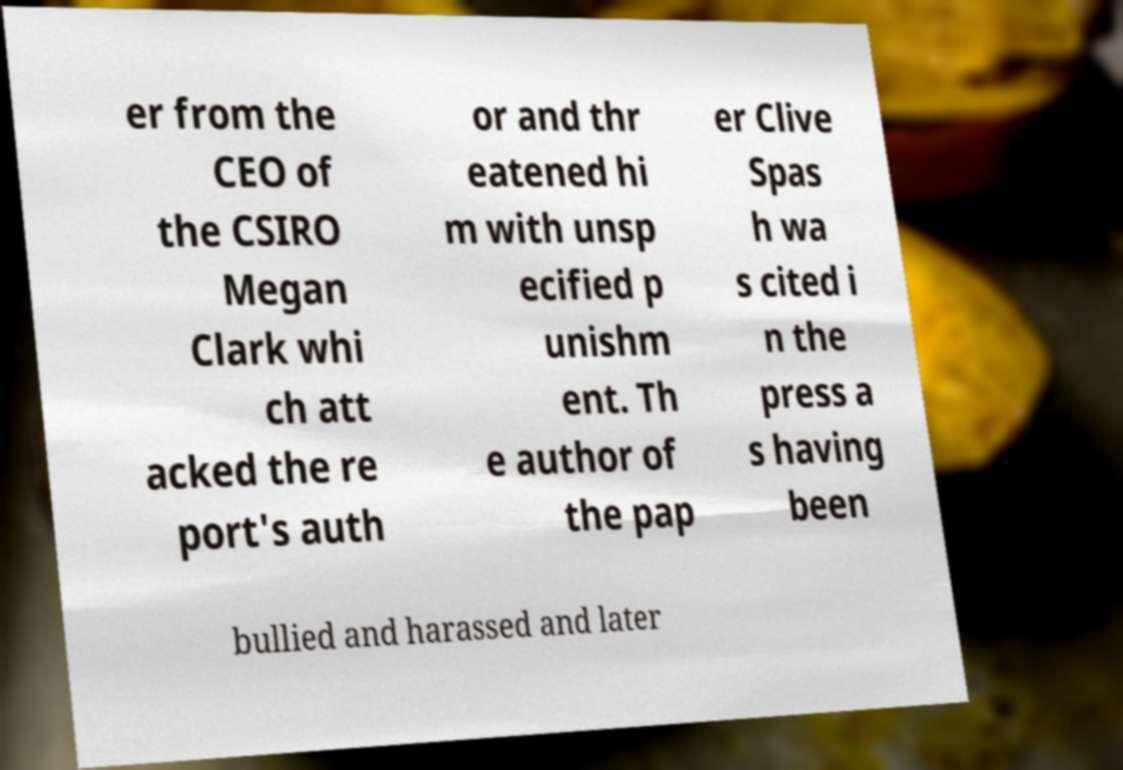Could you extract and type out the text from this image? er from the CEO of the CSIRO Megan Clark whi ch att acked the re port's auth or and thr eatened hi m with unsp ecified p unishm ent. Th e author of the pap er Clive Spas h wa s cited i n the press a s having been bullied and harassed and later 